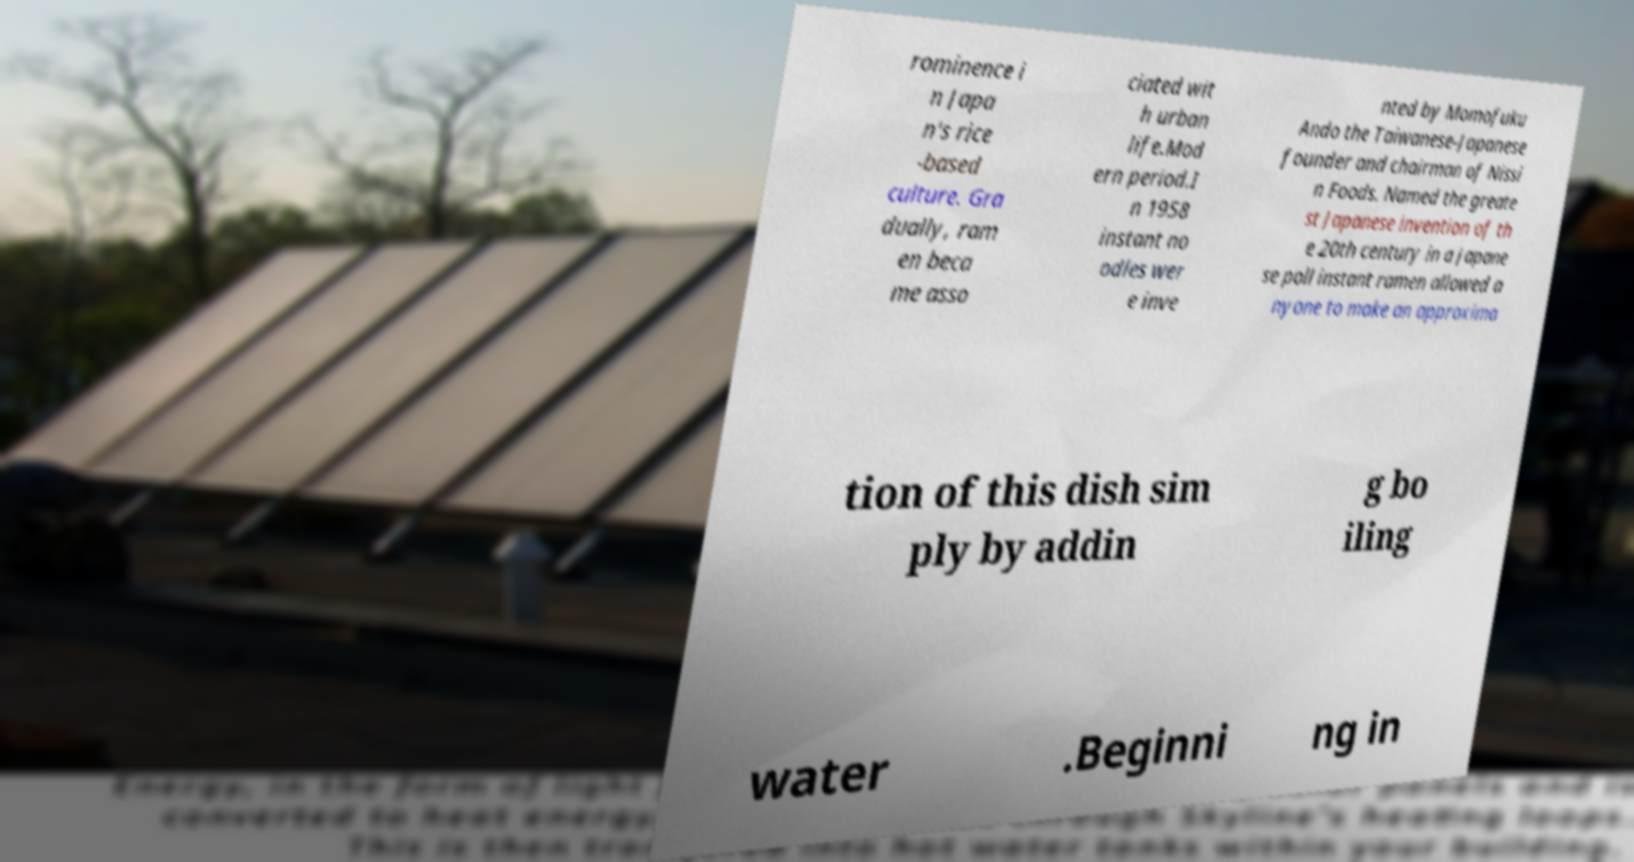There's text embedded in this image that I need extracted. Can you transcribe it verbatim? rominence i n Japa n's rice -based culture. Gra dually, ram en beca me asso ciated wit h urban life.Mod ern period.I n 1958 instant no odles wer e inve nted by Momofuku Ando the Taiwanese-Japanese founder and chairman of Nissi n Foods. Named the greate st Japanese invention of th e 20th century in a Japane se poll instant ramen allowed a nyone to make an approxima tion of this dish sim ply by addin g bo iling water .Beginni ng in 